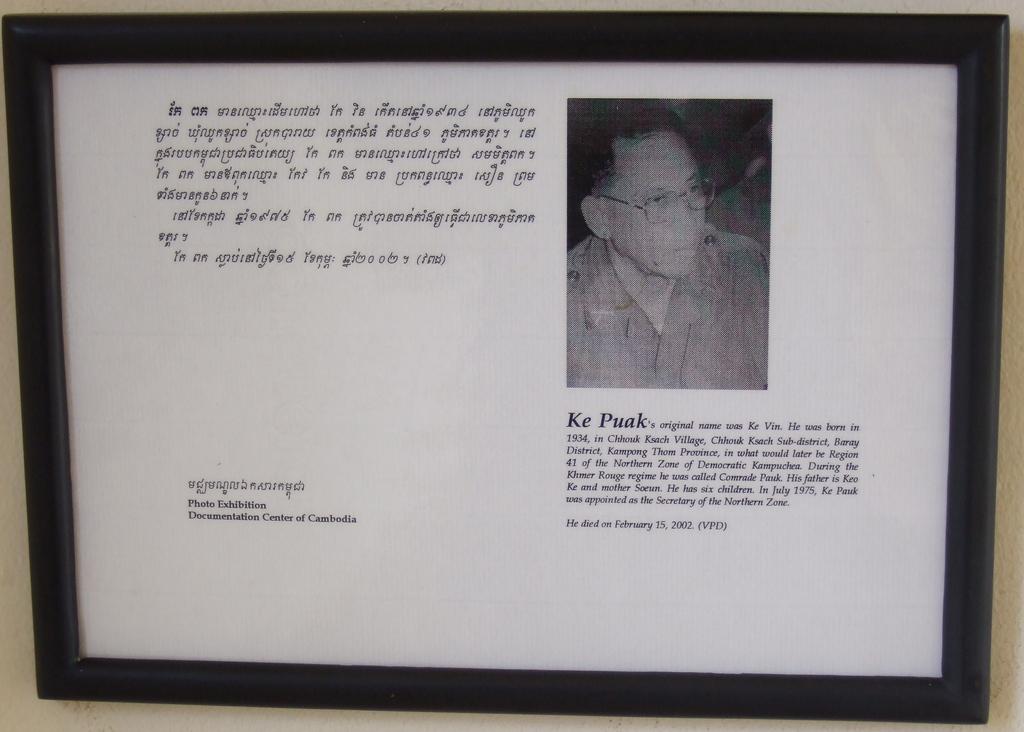What was his original name?
Your answer should be compact. Ke vin. 